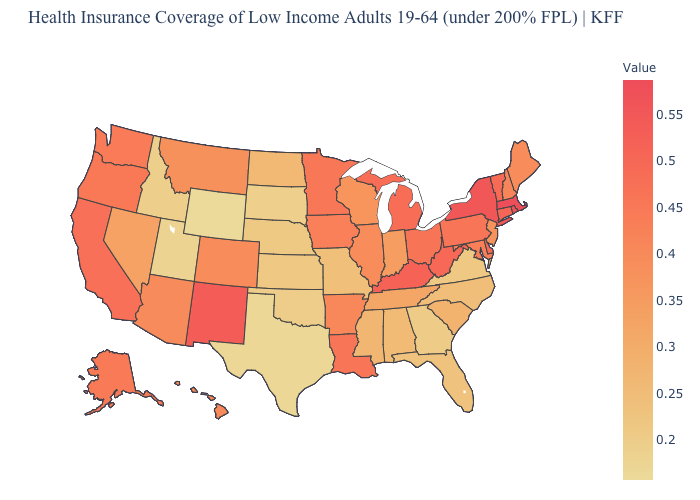Among the states that border Iowa , which have the lowest value?
Quick response, please. South Dakota. Is the legend a continuous bar?
Quick response, please. Yes. Among the states that border Montana , does Idaho have the lowest value?
Write a very short answer. No. Does the map have missing data?
Keep it brief. No. Which states have the lowest value in the USA?
Concise answer only. Wyoming. Which states hav the highest value in the West?
Answer briefly. New Mexico. Does Virginia have the lowest value in the USA?
Write a very short answer. No. 